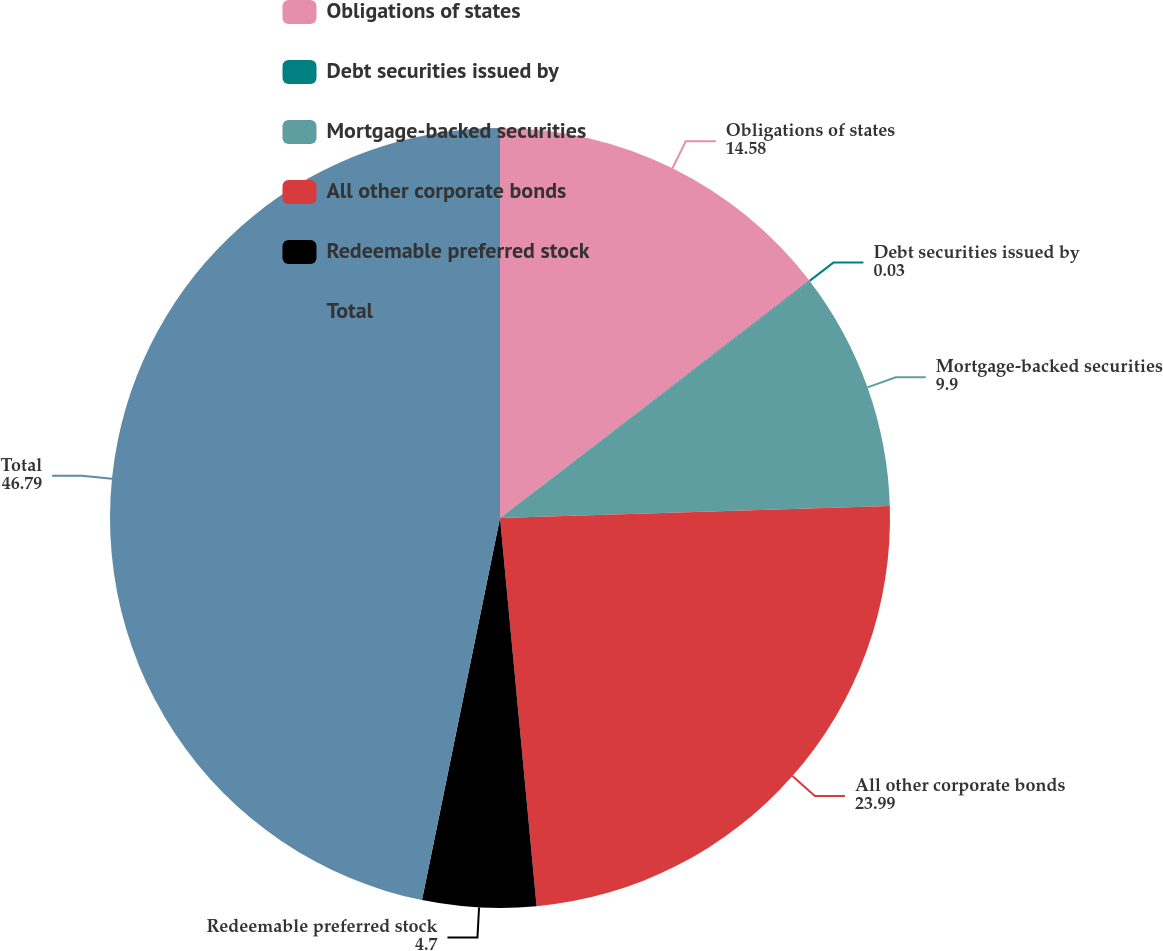Convert chart. <chart><loc_0><loc_0><loc_500><loc_500><pie_chart><fcel>Obligations of states<fcel>Debt securities issued by<fcel>Mortgage-backed securities<fcel>All other corporate bonds<fcel>Redeemable preferred stock<fcel>Total<nl><fcel>14.58%<fcel>0.03%<fcel>9.9%<fcel>23.99%<fcel>4.7%<fcel>46.79%<nl></chart> 